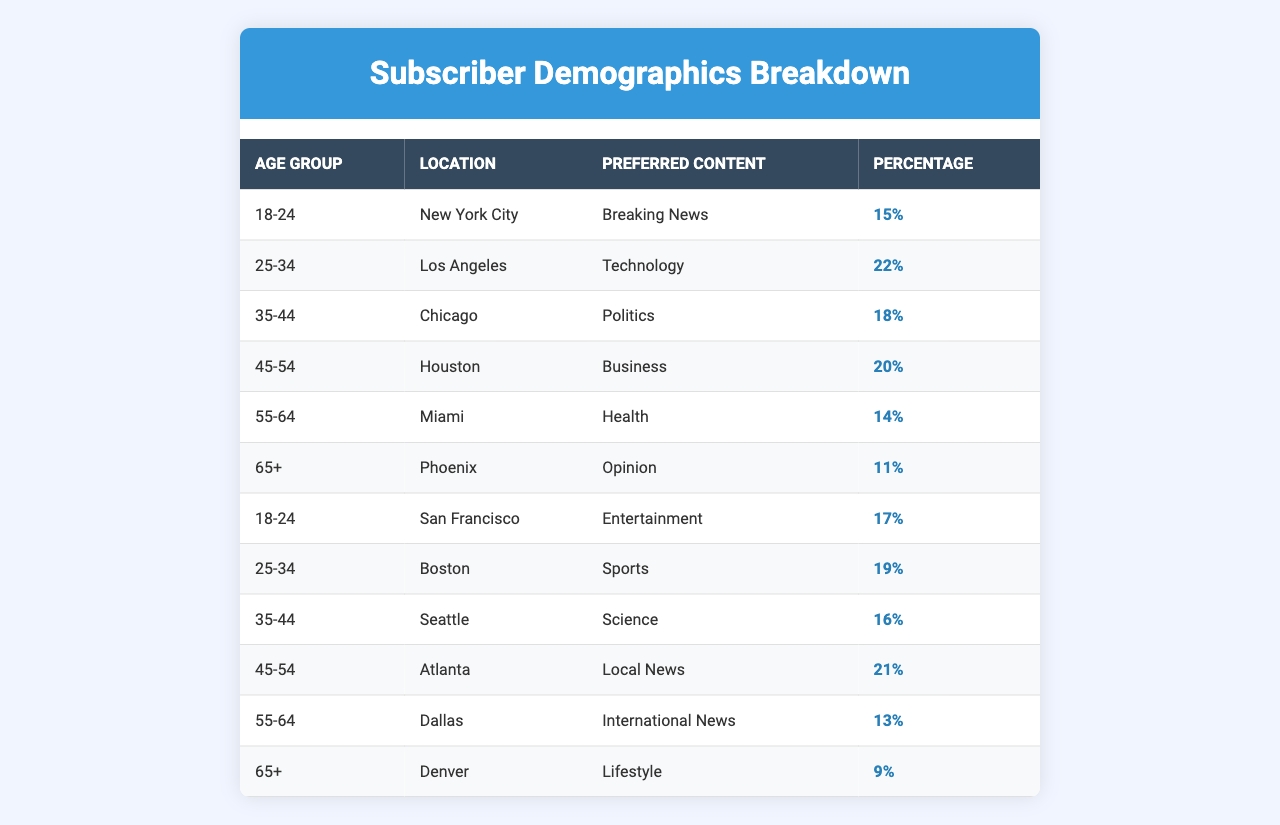What is the preferred content type for the age group 25-34 in Los Angeles? According to the table, the preferred content type for the age group 25-34 located in Los Angeles is Technology.
Answer: Technology Which age group has the highest percentage of subscribers in the table? In the table, the age group 45-54 has the highest percentage at 20%, compared to other groups.
Answer: 45-54 What is the percentage of subscribers aged 65+ who prefer Lifestyle content? The table indicates that 9% of subscribers aged 65+ prefer Lifestyle content.
Answer: 9% What is the average percentage of subscribers who prefer Breaking News across the different age groups? Breaking News is preferred by 15% for 18-24 in New York City, while there are no other age groups that prefer Breaking News. Thus, the average is 15% since it only applies to one group.
Answer: 15% Is there any age group in the table that has a preferred content type of Health? Yes, the age group 55-64 has a preferred content type of Health with a percentage of 14%.
Answer: Yes What is the total percentage of subscribers who prefer Sports and Science combined? Sports is preferred by 19% (age group 25-34 in Boston) and Science is preferred by 16% (age group 35-44 in Seattle). Adding these values gives 19% + 16% = 35%.
Answer: 35% Which city has the lowest percentage of subscribers in the table, and what is that percentage? The city with the lowest percentage is Denver, where the 65+ age group prefers Lifestyle content at 9%.
Answer: Denver, 9% How many subscribers from the 35-44 age group live in Chicago versus Seattle? In Chicago, the 35-44 age group has a percentage of 18%, while in Seattle, they have a percentage of 16%. Comparing these values shows that Chicago has a higher percentage than Seattle.
Answer: Chicago has a higher percentage Is there a preference for International News among the 55-64 age group in Dallas? Yes, the table shows that the 55-64 age group in Dallas prefers International News with a percentage of 13%.
Answer: Yes Based on the table, what can be inferred about the content preferences of subscribers aged 65+? The preferences for the 65+ age group show a lower percentage across all types, with the highest being 11% for Opinion in Phoenix and the lowest being 9% for Lifestyle in Denver, indicating a trend of lower engagement or interest in the offered content types compared to younger age groups.
Answer: They show lower engagement in content preferences 